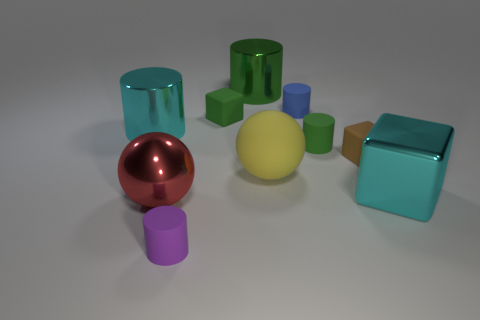Subtract all green cylinders. How many cylinders are left? 3 Subtract all green cylinders. How many cylinders are left? 3 Subtract all blue cylinders. Subtract all green spheres. How many cylinders are left? 4 Subtract all cubes. How many objects are left? 7 Subtract all large gray rubber blocks. Subtract all balls. How many objects are left? 8 Add 8 tiny purple rubber objects. How many tiny purple rubber objects are left? 9 Add 7 brown matte objects. How many brown matte objects exist? 8 Subtract 0 gray balls. How many objects are left? 10 